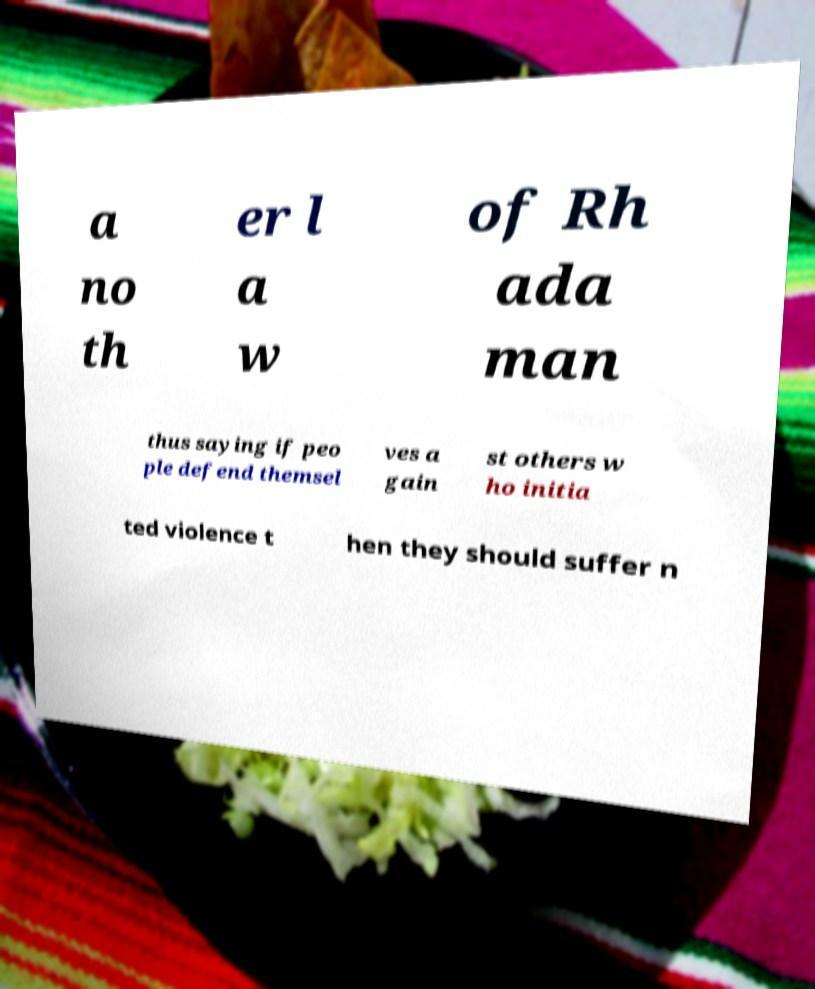Can you read and provide the text displayed in the image?This photo seems to have some interesting text. Can you extract and type it out for me? a no th er l a w of Rh ada man thus saying if peo ple defend themsel ves a gain st others w ho initia ted violence t hen they should suffer n 